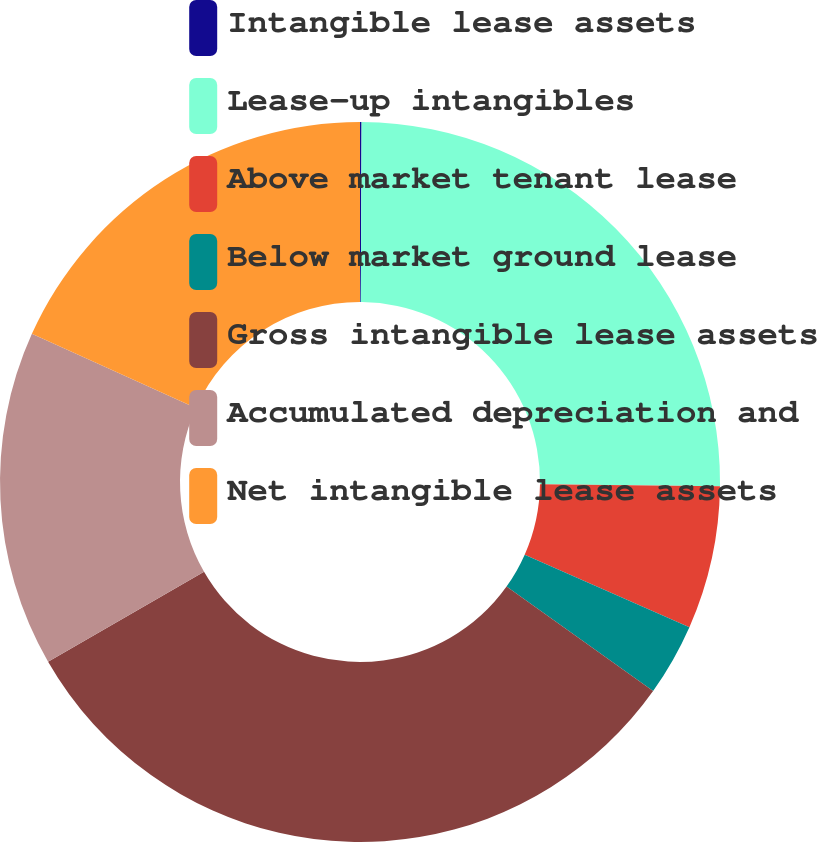Convert chart. <chart><loc_0><loc_0><loc_500><loc_500><pie_chart><fcel>Intangible lease assets<fcel>Lease-up intangibles<fcel>Above market tenant lease<fcel>Below market ground lease<fcel>Gross intangible lease assets<fcel>Accumulated depreciation and<fcel>Net intangible lease assets<nl><fcel>0.07%<fcel>25.12%<fcel>6.42%<fcel>3.25%<fcel>31.82%<fcel>15.07%<fcel>18.25%<nl></chart> 